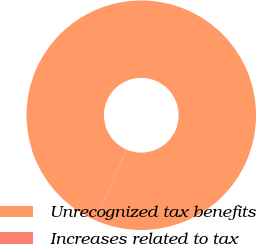Convert chart to OTSL. <chart><loc_0><loc_0><loc_500><loc_500><pie_chart><fcel>Unrecognized tax benefits<fcel>Increases related to tax<nl><fcel>99.86%<fcel>0.14%<nl></chart> 